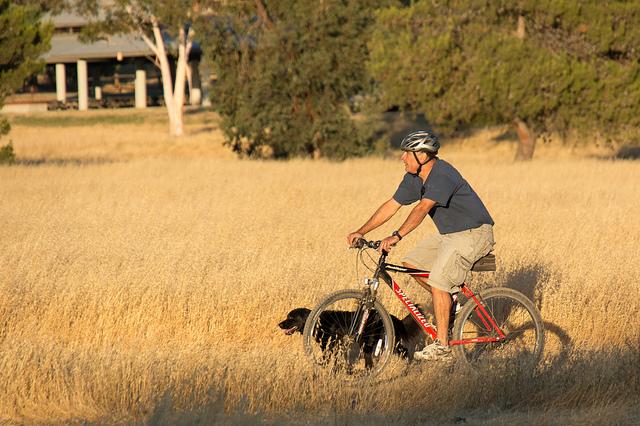What is the man wearing on his head?
Keep it brief. Helmet. Is the man wearing a long sleeve shirt?
Answer briefly. No. Is the man racing or touring?
Short answer required. Touring. Is the man being safe?
Short answer required. Yes. Is this man trying to be young again?
Write a very short answer. No. Is the man wearing any safety equipment?
Be succinct. Yes. Are they on a trail?
Short answer required. No. Is the dog chasing the bike?
Quick response, please. No. 